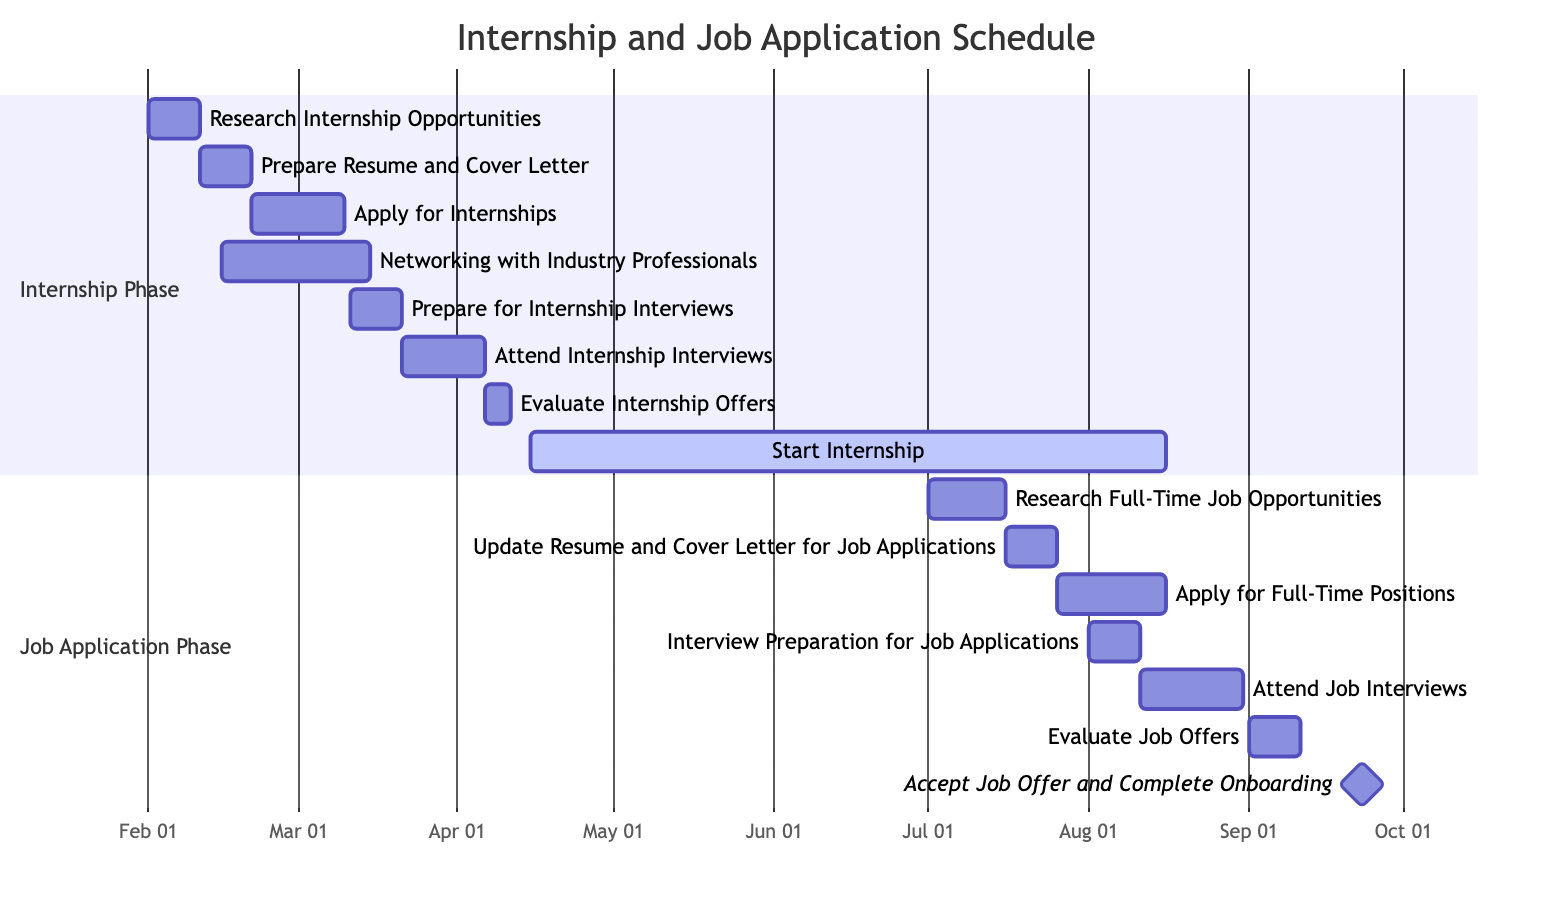What is the start date for the "Networking with Industry Professionals" task? The task "Networking with Industry Professionals" starts on February 15, 2024, as shown in the timeline.
Answer: February 15, 2024 How long is the "Apply for Internships" task scheduled to last? The "Apply for Internships" task starts on February 21, 2024, and ends on March 10, 2024. This gives it a duration of 18 days.
Answer: 18 days Which task overlaps with the "Prepare for Internship Interviews"? The "Networking with Industry Professionals" task overlaps with "Prepare for Internship Interviews" as it runs from February 15, 2024, to March 15, 2024, while the interview preparation is from March 11, 2024, to March 20, 2024.
Answer: Networking with Industry Professionals What is the total duration of the "Start Internship" task? The "Start Internship" task runs from April 15, 2024, to August 15, 2024. This is a total of 123 days, as indicated by the timeline.
Answer: 123 days How many tasks are in the Job Application Phase? In the Job Application Phase, there are six tasks listed, starting from "Research Full-Time Job Opportunities" to "Accept Job Offer and Complete Onboarding."
Answer: 6 tasks What is the milestone date for "Accept Job Offer and Complete Onboarding"? The "Accept Job Offer and Complete Onboarding" task is marked as a milestone with a date of September 15, 2024.
Answer: September 15, 2024 When does the "Update Resume and Cover Letter for Job Applications" task begin? The task "Update Resume and Cover Letter for Job Applications" begins on July 16, 2024, per the timeline shown.
Answer: July 16, 2024 Which task follows the "Attend Job Interviews"? The task that follows "Attend Job Interviews," which ends on August 30, 2024, is "Evaluate Job Offers," starting on September 1, 2024.
Answer: Evaluate Job Offers 